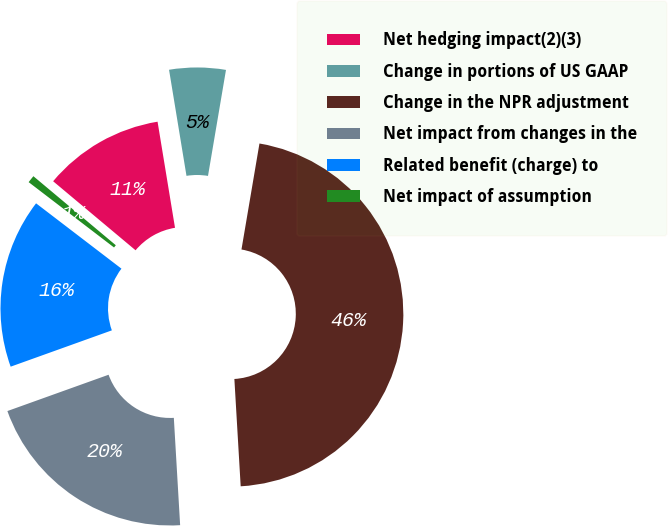<chart> <loc_0><loc_0><loc_500><loc_500><pie_chart><fcel>Net hedging impact(2)(3)<fcel>Change in portions of US GAAP<fcel>Change in the NPR adjustment<fcel>Net impact from changes in the<fcel>Related benefit (charge) to<fcel>Net impact of assumption<nl><fcel>11.31%<fcel>5.27%<fcel>46.39%<fcel>20.45%<fcel>15.88%<fcel>0.7%<nl></chart> 